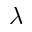Convert formula to latex. <formula><loc_0><loc_0><loc_500><loc_500>\lambda</formula> 